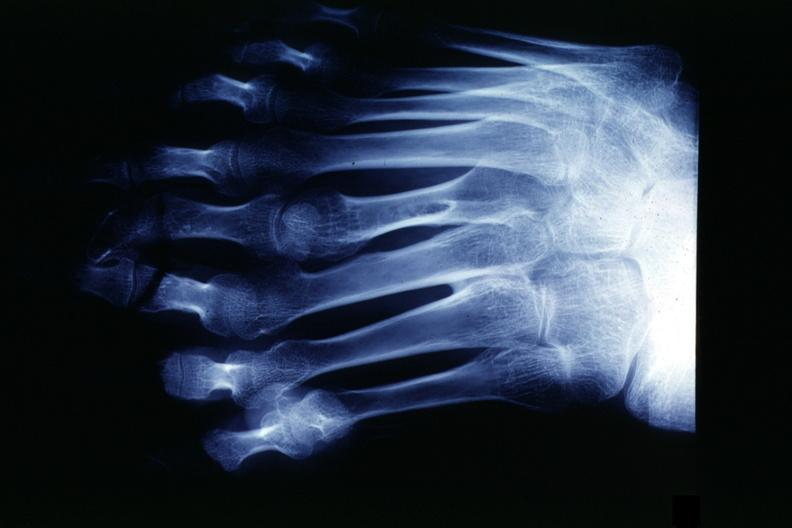what does this image show?
Answer the question using a single word or phrase. X-ray strange foot with 8 digits 